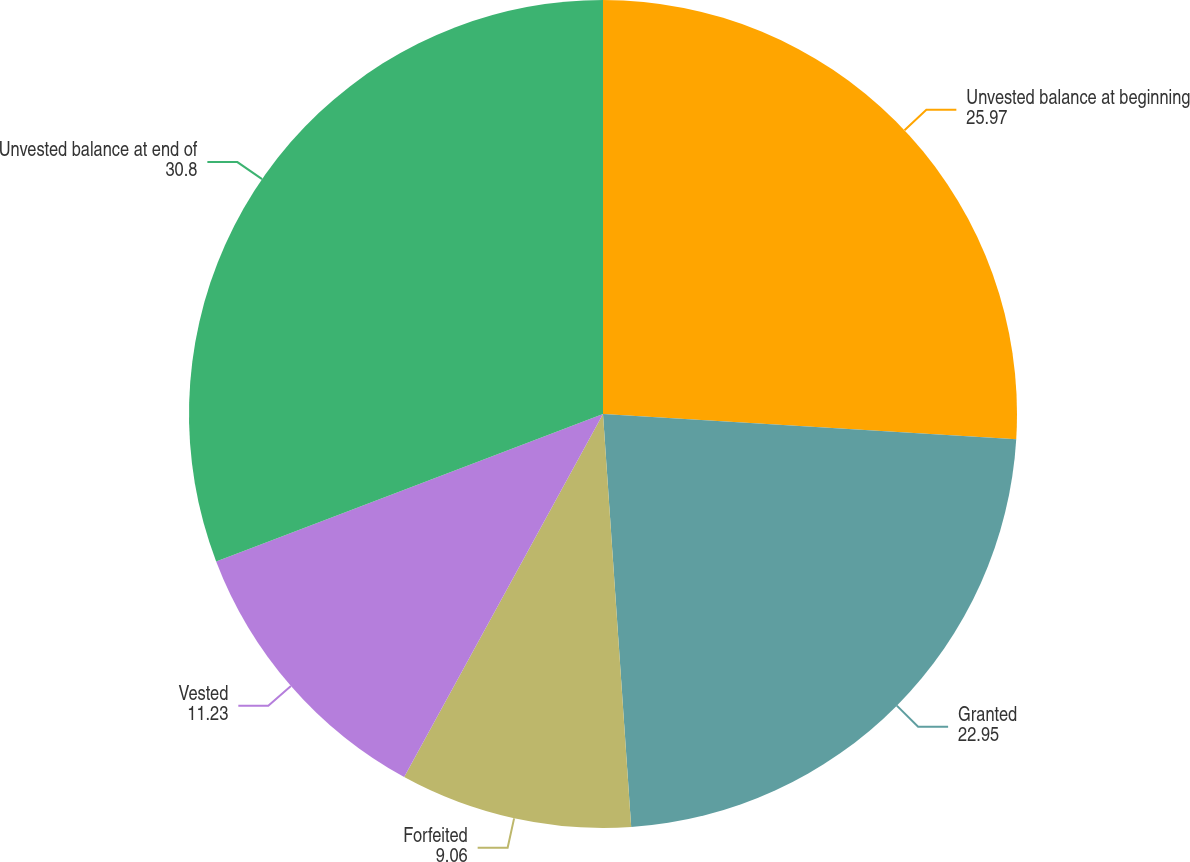<chart> <loc_0><loc_0><loc_500><loc_500><pie_chart><fcel>Unvested balance at beginning<fcel>Granted<fcel>Forfeited<fcel>Vested<fcel>Unvested balance at end of<nl><fcel>25.97%<fcel>22.95%<fcel>9.06%<fcel>11.23%<fcel>30.8%<nl></chart> 